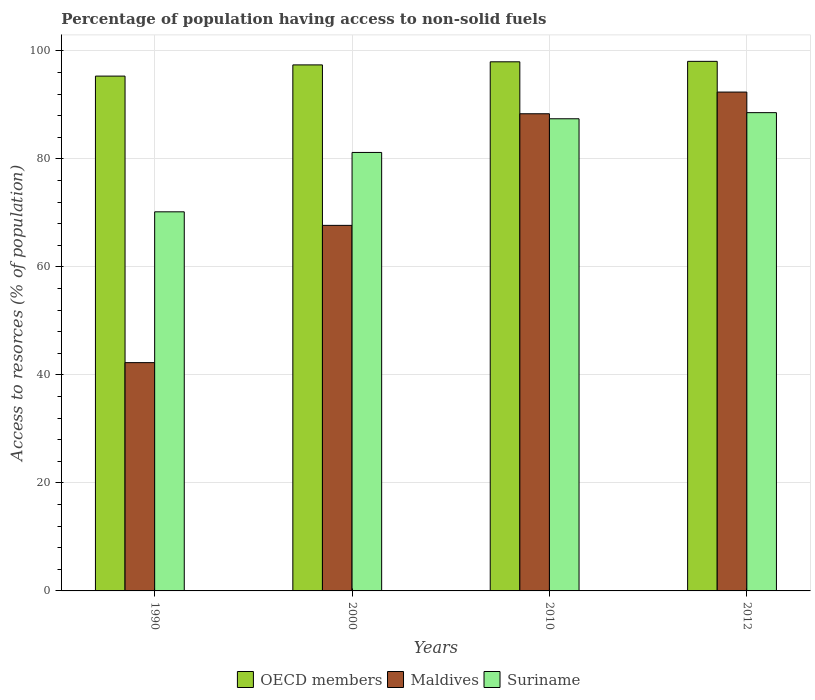How many different coloured bars are there?
Offer a terse response. 3. Are the number of bars on each tick of the X-axis equal?
Provide a succinct answer. Yes. How many bars are there on the 1st tick from the right?
Offer a terse response. 3. What is the label of the 2nd group of bars from the left?
Make the answer very short. 2000. What is the percentage of population having access to non-solid fuels in Suriname in 2010?
Your answer should be very brief. 87.44. Across all years, what is the maximum percentage of population having access to non-solid fuels in OECD members?
Offer a terse response. 98.07. Across all years, what is the minimum percentage of population having access to non-solid fuels in Maldives?
Keep it short and to the point. 42.28. In which year was the percentage of population having access to non-solid fuels in Suriname minimum?
Your response must be concise. 1990. What is the total percentage of population having access to non-solid fuels in Suriname in the graph?
Ensure brevity in your answer.  327.43. What is the difference between the percentage of population having access to non-solid fuels in Maldives in 2000 and that in 2012?
Keep it short and to the point. -24.69. What is the difference between the percentage of population having access to non-solid fuels in Suriname in 2012 and the percentage of population having access to non-solid fuels in Maldives in 1990?
Make the answer very short. 46.3. What is the average percentage of population having access to non-solid fuels in Suriname per year?
Your answer should be compact. 81.86. In the year 2000, what is the difference between the percentage of population having access to non-solid fuels in OECD members and percentage of population having access to non-solid fuels in Suriname?
Ensure brevity in your answer.  16.21. In how many years, is the percentage of population having access to non-solid fuels in OECD members greater than 24 %?
Offer a terse response. 4. What is the ratio of the percentage of population having access to non-solid fuels in OECD members in 1990 to that in 2000?
Your response must be concise. 0.98. Is the difference between the percentage of population having access to non-solid fuels in OECD members in 2000 and 2012 greater than the difference between the percentage of population having access to non-solid fuels in Suriname in 2000 and 2012?
Ensure brevity in your answer.  Yes. What is the difference between the highest and the second highest percentage of population having access to non-solid fuels in Maldives?
Provide a succinct answer. 4.02. What is the difference between the highest and the lowest percentage of population having access to non-solid fuels in OECD members?
Offer a terse response. 2.73. Is the sum of the percentage of population having access to non-solid fuels in Suriname in 2000 and 2010 greater than the maximum percentage of population having access to non-solid fuels in Maldives across all years?
Your response must be concise. Yes. What does the 1st bar from the right in 2012 represents?
Your answer should be very brief. Suriname. How many years are there in the graph?
Make the answer very short. 4. Are the values on the major ticks of Y-axis written in scientific E-notation?
Ensure brevity in your answer.  No. How are the legend labels stacked?
Give a very brief answer. Horizontal. What is the title of the graph?
Keep it short and to the point. Percentage of population having access to non-solid fuels. What is the label or title of the Y-axis?
Offer a very short reply. Access to resorces (% of population). What is the Access to resorces (% of population) in OECD members in 1990?
Your answer should be compact. 95.34. What is the Access to resorces (% of population) of Maldives in 1990?
Give a very brief answer. 42.28. What is the Access to resorces (% of population) of Suriname in 1990?
Provide a succinct answer. 70.21. What is the Access to resorces (% of population) of OECD members in 2000?
Offer a very short reply. 97.42. What is the Access to resorces (% of population) of Maldives in 2000?
Offer a terse response. 67.7. What is the Access to resorces (% of population) in Suriname in 2000?
Your answer should be very brief. 81.2. What is the Access to resorces (% of population) of OECD members in 2010?
Ensure brevity in your answer.  97.99. What is the Access to resorces (% of population) of Maldives in 2010?
Your response must be concise. 88.37. What is the Access to resorces (% of population) of Suriname in 2010?
Your answer should be very brief. 87.44. What is the Access to resorces (% of population) in OECD members in 2012?
Your response must be concise. 98.07. What is the Access to resorces (% of population) in Maldives in 2012?
Offer a very short reply. 92.39. What is the Access to resorces (% of population) in Suriname in 2012?
Offer a very short reply. 88.57. Across all years, what is the maximum Access to resorces (% of population) of OECD members?
Offer a terse response. 98.07. Across all years, what is the maximum Access to resorces (% of population) of Maldives?
Your answer should be compact. 92.39. Across all years, what is the maximum Access to resorces (% of population) in Suriname?
Keep it short and to the point. 88.57. Across all years, what is the minimum Access to resorces (% of population) in OECD members?
Your answer should be compact. 95.34. Across all years, what is the minimum Access to resorces (% of population) in Maldives?
Your answer should be compact. 42.28. Across all years, what is the minimum Access to resorces (% of population) of Suriname?
Give a very brief answer. 70.21. What is the total Access to resorces (% of population) in OECD members in the graph?
Your answer should be compact. 388.83. What is the total Access to resorces (% of population) of Maldives in the graph?
Your response must be concise. 290.73. What is the total Access to resorces (% of population) of Suriname in the graph?
Provide a succinct answer. 327.43. What is the difference between the Access to resorces (% of population) in OECD members in 1990 and that in 2000?
Your answer should be compact. -2.07. What is the difference between the Access to resorces (% of population) in Maldives in 1990 and that in 2000?
Offer a very short reply. -25.42. What is the difference between the Access to resorces (% of population) in Suriname in 1990 and that in 2000?
Your response must be concise. -11. What is the difference between the Access to resorces (% of population) in OECD members in 1990 and that in 2010?
Offer a very short reply. -2.65. What is the difference between the Access to resorces (% of population) in Maldives in 1990 and that in 2010?
Your response must be concise. -46.09. What is the difference between the Access to resorces (% of population) of Suriname in 1990 and that in 2010?
Your answer should be compact. -17.23. What is the difference between the Access to resorces (% of population) in OECD members in 1990 and that in 2012?
Give a very brief answer. -2.73. What is the difference between the Access to resorces (% of population) of Maldives in 1990 and that in 2012?
Your answer should be compact. -50.11. What is the difference between the Access to resorces (% of population) in Suriname in 1990 and that in 2012?
Keep it short and to the point. -18.37. What is the difference between the Access to resorces (% of population) in OECD members in 2000 and that in 2010?
Your answer should be very brief. -0.57. What is the difference between the Access to resorces (% of population) of Maldives in 2000 and that in 2010?
Make the answer very short. -20.67. What is the difference between the Access to resorces (% of population) of Suriname in 2000 and that in 2010?
Ensure brevity in your answer.  -6.24. What is the difference between the Access to resorces (% of population) in OECD members in 2000 and that in 2012?
Provide a succinct answer. -0.66. What is the difference between the Access to resorces (% of population) of Maldives in 2000 and that in 2012?
Your response must be concise. -24.69. What is the difference between the Access to resorces (% of population) of Suriname in 2000 and that in 2012?
Give a very brief answer. -7.37. What is the difference between the Access to resorces (% of population) in OECD members in 2010 and that in 2012?
Your answer should be compact. -0.08. What is the difference between the Access to resorces (% of population) in Maldives in 2010 and that in 2012?
Provide a short and direct response. -4.02. What is the difference between the Access to resorces (% of population) in Suriname in 2010 and that in 2012?
Offer a terse response. -1.13. What is the difference between the Access to resorces (% of population) in OECD members in 1990 and the Access to resorces (% of population) in Maldives in 2000?
Your response must be concise. 27.65. What is the difference between the Access to resorces (% of population) of OECD members in 1990 and the Access to resorces (% of population) of Suriname in 2000?
Provide a succinct answer. 14.14. What is the difference between the Access to resorces (% of population) in Maldives in 1990 and the Access to resorces (% of population) in Suriname in 2000?
Provide a short and direct response. -38.93. What is the difference between the Access to resorces (% of population) of OECD members in 1990 and the Access to resorces (% of population) of Maldives in 2010?
Provide a succinct answer. 6.98. What is the difference between the Access to resorces (% of population) of OECD members in 1990 and the Access to resorces (% of population) of Suriname in 2010?
Provide a short and direct response. 7.9. What is the difference between the Access to resorces (% of population) in Maldives in 1990 and the Access to resorces (% of population) in Suriname in 2010?
Provide a short and direct response. -45.16. What is the difference between the Access to resorces (% of population) in OECD members in 1990 and the Access to resorces (% of population) in Maldives in 2012?
Give a very brief answer. 2.96. What is the difference between the Access to resorces (% of population) in OECD members in 1990 and the Access to resorces (% of population) in Suriname in 2012?
Your answer should be very brief. 6.77. What is the difference between the Access to resorces (% of population) in Maldives in 1990 and the Access to resorces (% of population) in Suriname in 2012?
Offer a terse response. -46.3. What is the difference between the Access to resorces (% of population) of OECD members in 2000 and the Access to resorces (% of population) of Maldives in 2010?
Your response must be concise. 9.05. What is the difference between the Access to resorces (% of population) in OECD members in 2000 and the Access to resorces (% of population) in Suriname in 2010?
Give a very brief answer. 9.98. What is the difference between the Access to resorces (% of population) of Maldives in 2000 and the Access to resorces (% of population) of Suriname in 2010?
Offer a terse response. -19.74. What is the difference between the Access to resorces (% of population) of OECD members in 2000 and the Access to resorces (% of population) of Maldives in 2012?
Offer a very short reply. 5.03. What is the difference between the Access to resorces (% of population) of OECD members in 2000 and the Access to resorces (% of population) of Suriname in 2012?
Your response must be concise. 8.84. What is the difference between the Access to resorces (% of population) of Maldives in 2000 and the Access to resorces (% of population) of Suriname in 2012?
Ensure brevity in your answer.  -20.88. What is the difference between the Access to resorces (% of population) of OECD members in 2010 and the Access to resorces (% of population) of Maldives in 2012?
Give a very brief answer. 5.61. What is the difference between the Access to resorces (% of population) of OECD members in 2010 and the Access to resorces (% of population) of Suriname in 2012?
Provide a succinct answer. 9.42. What is the difference between the Access to resorces (% of population) of Maldives in 2010 and the Access to resorces (% of population) of Suriname in 2012?
Ensure brevity in your answer.  -0.21. What is the average Access to resorces (% of population) of OECD members per year?
Give a very brief answer. 97.21. What is the average Access to resorces (% of population) in Maldives per year?
Your answer should be compact. 72.68. What is the average Access to resorces (% of population) of Suriname per year?
Ensure brevity in your answer.  81.86. In the year 1990, what is the difference between the Access to resorces (% of population) of OECD members and Access to resorces (% of population) of Maldives?
Make the answer very short. 53.07. In the year 1990, what is the difference between the Access to resorces (% of population) in OECD members and Access to resorces (% of population) in Suriname?
Your answer should be very brief. 25.14. In the year 1990, what is the difference between the Access to resorces (% of population) in Maldives and Access to resorces (% of population) in Suriname?
Provide a succinct answer. -27.93. In the year 2000, what is the difference between the Access to resorces (% of population) of OECD members and Access to resorces (% of population) of Maldives?
Your response must be concise. 29.72. In the year 2000, what is the difference between the Access to resorces (% of population) in OECD members and Access to resorces (% of population) in Suriname?
Keep it short and to the point. 16.21. In the year 2000, what is the difference between the Access to resorces (% of population) in Maldives and Access to resorces (% of population) in Suriname?
Provide a succinct answer. -13.51. In the year 2010, what is the difference between the Access to resorces (% of population) of OECD members and Access to resorces (% of population) of Maldives?
Offer a very short reply. 9.62. In the year 2010, what is the difference between the Access to resorces (% of population) in OECD members and Access to resorces (% of population) in Suriname?
Offer a very short reply. 10.55. In the year 2010, what is the difference between the Access to resorces (% of population) in Maldives and Access to resorces (% of population) in Suriname?
Provide a succinct answer. 0.93. In the year 2012, what is the difference between the Access to resorces (% of population) of OECD members and Access to resorces (% of population) of Maldives?
Provide a succinct answer. 5.69. In the year 2012, what is the difference between the Access to resorces (% of population) in OECD members and Access to resorces (% of population) in Suriname?
Give a very brief answer. 9.5. In the year 2012, what is the difference between the Access to resorces (% of population) of Maldives and Access to resorces (% of population) of Suriname?
Your response must be concise. 3.81. What is the ratio of the Access to resorces (% of population) of OECD members in 1990 to that in 2000?
Provide a short and direct response. 0.98. What is the ratio of the Access to resorces (% of population) in Maldives in 1990 to that in 2000?
Your answer should be very brief. 0.62. What is the ratio of the Access to resorces (% of population) of Suriname in 1990 to that in 2000?
Your response must be concise. 0.86. What is the ratio of the Access to resorces (% of population) in Maldives in 1990 to that in 2010?
Your answer should be very brief. 0.48. What is the ratio of the Access to resorces (% of population) of Suriname in 1990 to that in 2010?
Provide a short and direct response. 0.8. What is the ratio of the Access to resorces (% of population) in OECD members in 1990 to that in 2012?
Keep it short and to the point. 0.97. What is the ratio of the Access to resorces (% of population) of Maldives in 1990 to that in 2012?
Provide a succinct answer. 0.46. What is the ratio of the Access to resorces (% of population) in Suriname in 1990 to that in 2012?
Your answer should be compact. 0.79. What is the ratio of the Access to resorces (% of population) in OECD members in 2000 to that in 2010?
Make the answer very short. 0.99. What is the ratio of the Access to resorces (% of population) in Maldives in 2000 to that in 2010?
Your answer should be very brief. 0.77. What is the ratio of the Access to resorces (% of population) in Suriname in 2000 to that in 2010?
Your answer should be compact. 0.93. What is the ratio of the Access to resorces (% of population) in Maldives in 2000 to that in 2012?
Your answer should be very brief. 0.73. What is the ratio of the Access to resorces (% of population) in Suriname in 2000 to that in 2012?
Provide a succinct answer. 0.92. What is the ratio of the Access to resorces (% of population) in OECD members in 2010 to that in 2012?
Offer a terse response. 1. What is the ratio of the Access to resorces (% of population) of Maldives in 2010 to that in 2012?
Your answer should be compact. 0.96. What is the ratio of the Access to resorces (% of population) of Suriname in 2010 to that in 2012?
Keep it short and to the point. 0.99. What is the difference between the highest and the second highest Access to resorces (% of population) of OECD members?
Provide a succinct answer. 0.08. What is the difference between the highest and the second highest Access to resorces (% of population) of Maldives?
Give a very brief answer. 4.02. What is the difference between the highest and the second highest Access to resorces (% of population) in Suriname?
Your answer should be compact. 1.13. What is the difference between the highest and the lowest Access to resorces (% of population) of OECD members?
Provide a short and direct response. 2.73. What is the difference between the highest and the lowest Access to resorces (% of population) in Maldives?
Offer a terse response. 50.11. What is the difference between the highest and the lowest Access to resorces (% of population) of Suriname?
Your answer should be very brief. 18.37. 